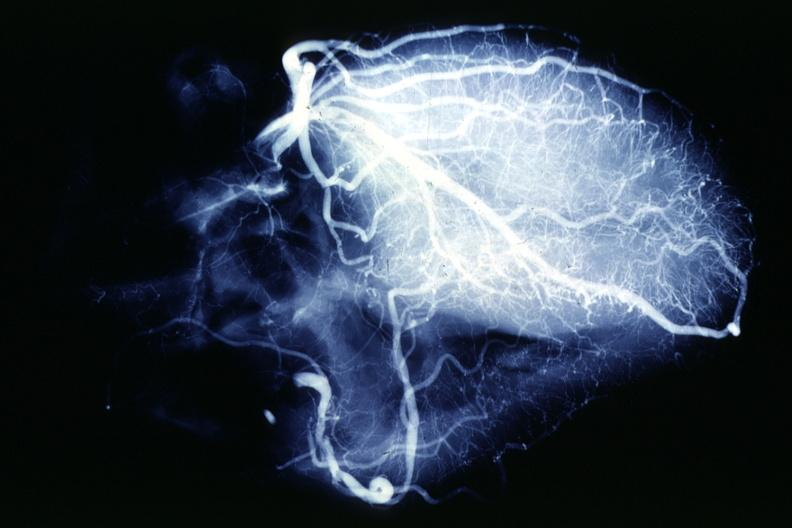where is this from?
Answer the question using a single word or phrase. Heart 